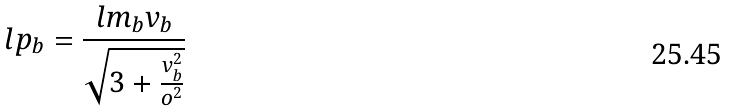<formula> <loc_0><loc_0><loc_500><loc_500>l p _ { b } = \frac { l m _ { b } v _ { b } } { \sqrt { 3 + \frac { v _ { b } ^ { 2 } } { o ^ { 2 } } } }</formula> 